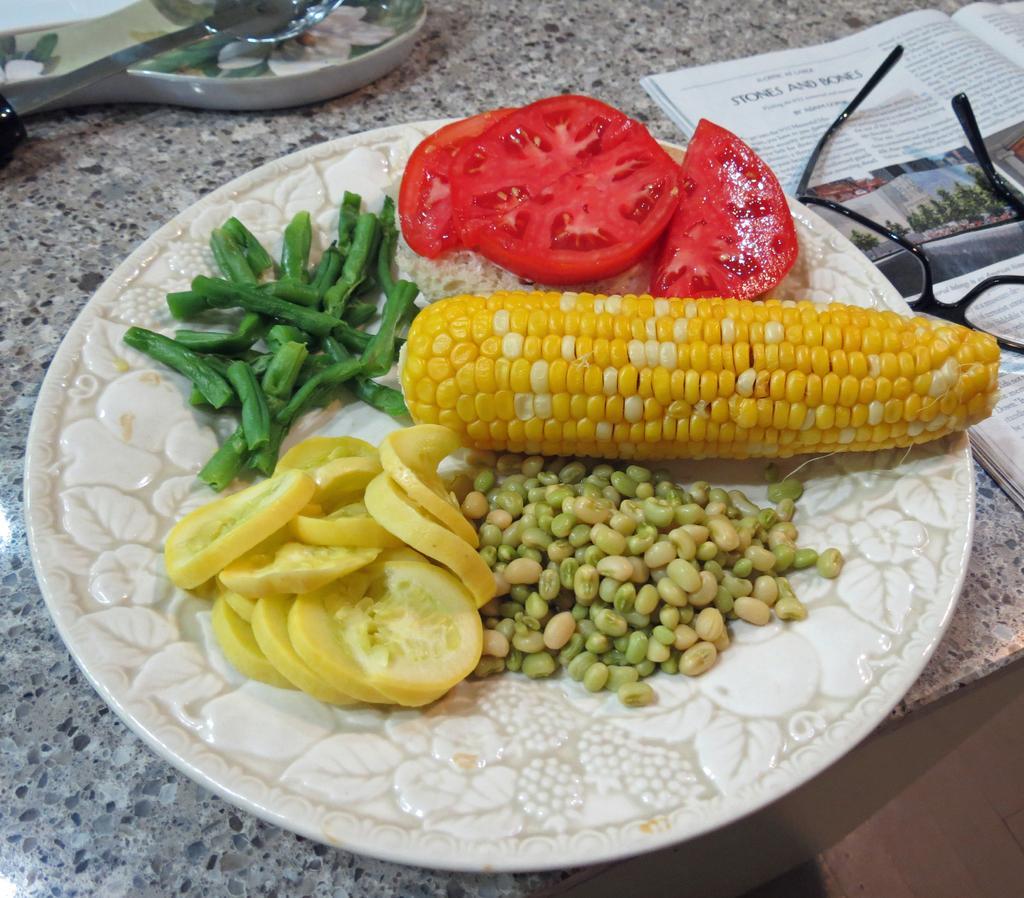Can you describe this image briefly? In the image there is corn,beans,cucumber,tomato slices in a plate on kitchen platform with newspaper,glasses and spoon on it. 